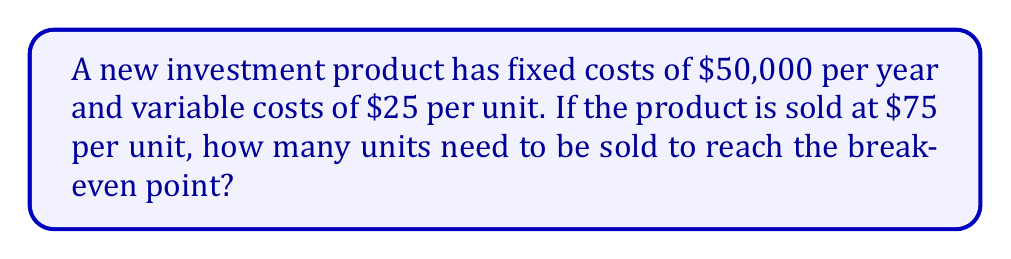Teach me how to tackle this problem. To determine the break-even point, we need to find the number of units where total revenue equals total costs.

Let $x$ be the number of units sold.

1) Total Revenue (TR): $\text{TR} = 75x$

2) Total Costs (TC): $\text{TC} = 50000 + 25x$

3) At break-even point: $\text{TR} = \text{TC}$

4) Set up the equation:
   $$75x = 50000 + 25x$$

5) Solve for $x$:
   $$75x - 25x = 50000$$
   $$50x = 50000$$
   $$x = \frac{50000}{50} = 1000$$

Therefore, 1000 units need to be sold to reach the break-even point.
Answer: 1000 units 